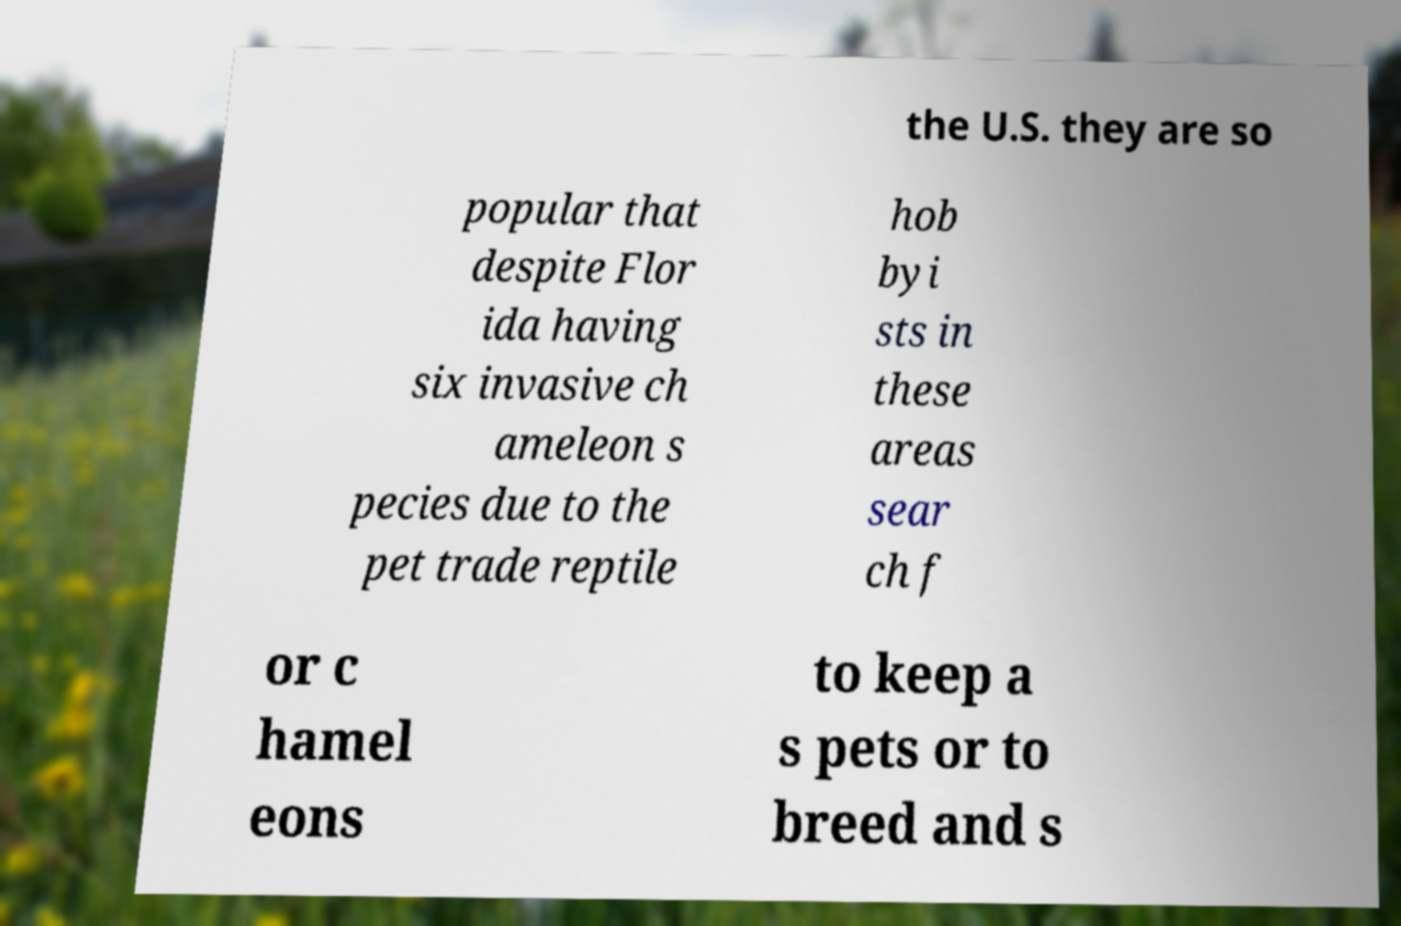Please identify and transcribe the text found in this image. the U.S. they are so popular that despite Flor ida having six invasive ch ameleon s pecies due to the pet trade reptile hob byi sts in these areas sear ch f or c hamel eons to keep a s pets or to breed and s 